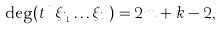<formula> <loc_0><loc_0><loc_500><loc_500>\deg ( t ^ { m } \xi _ { i _ { 1 } } \dots \xi _ { i _ { k } } ) = 2 m + k - 2 ,</formula> 